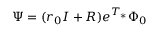<formula> <loc_0><loc_0><loc_500><loc_500>\Psi = ( r _ { 0 } I + R ) e ^ { T _ { * } } \Phi _ { 0 }</formula> 